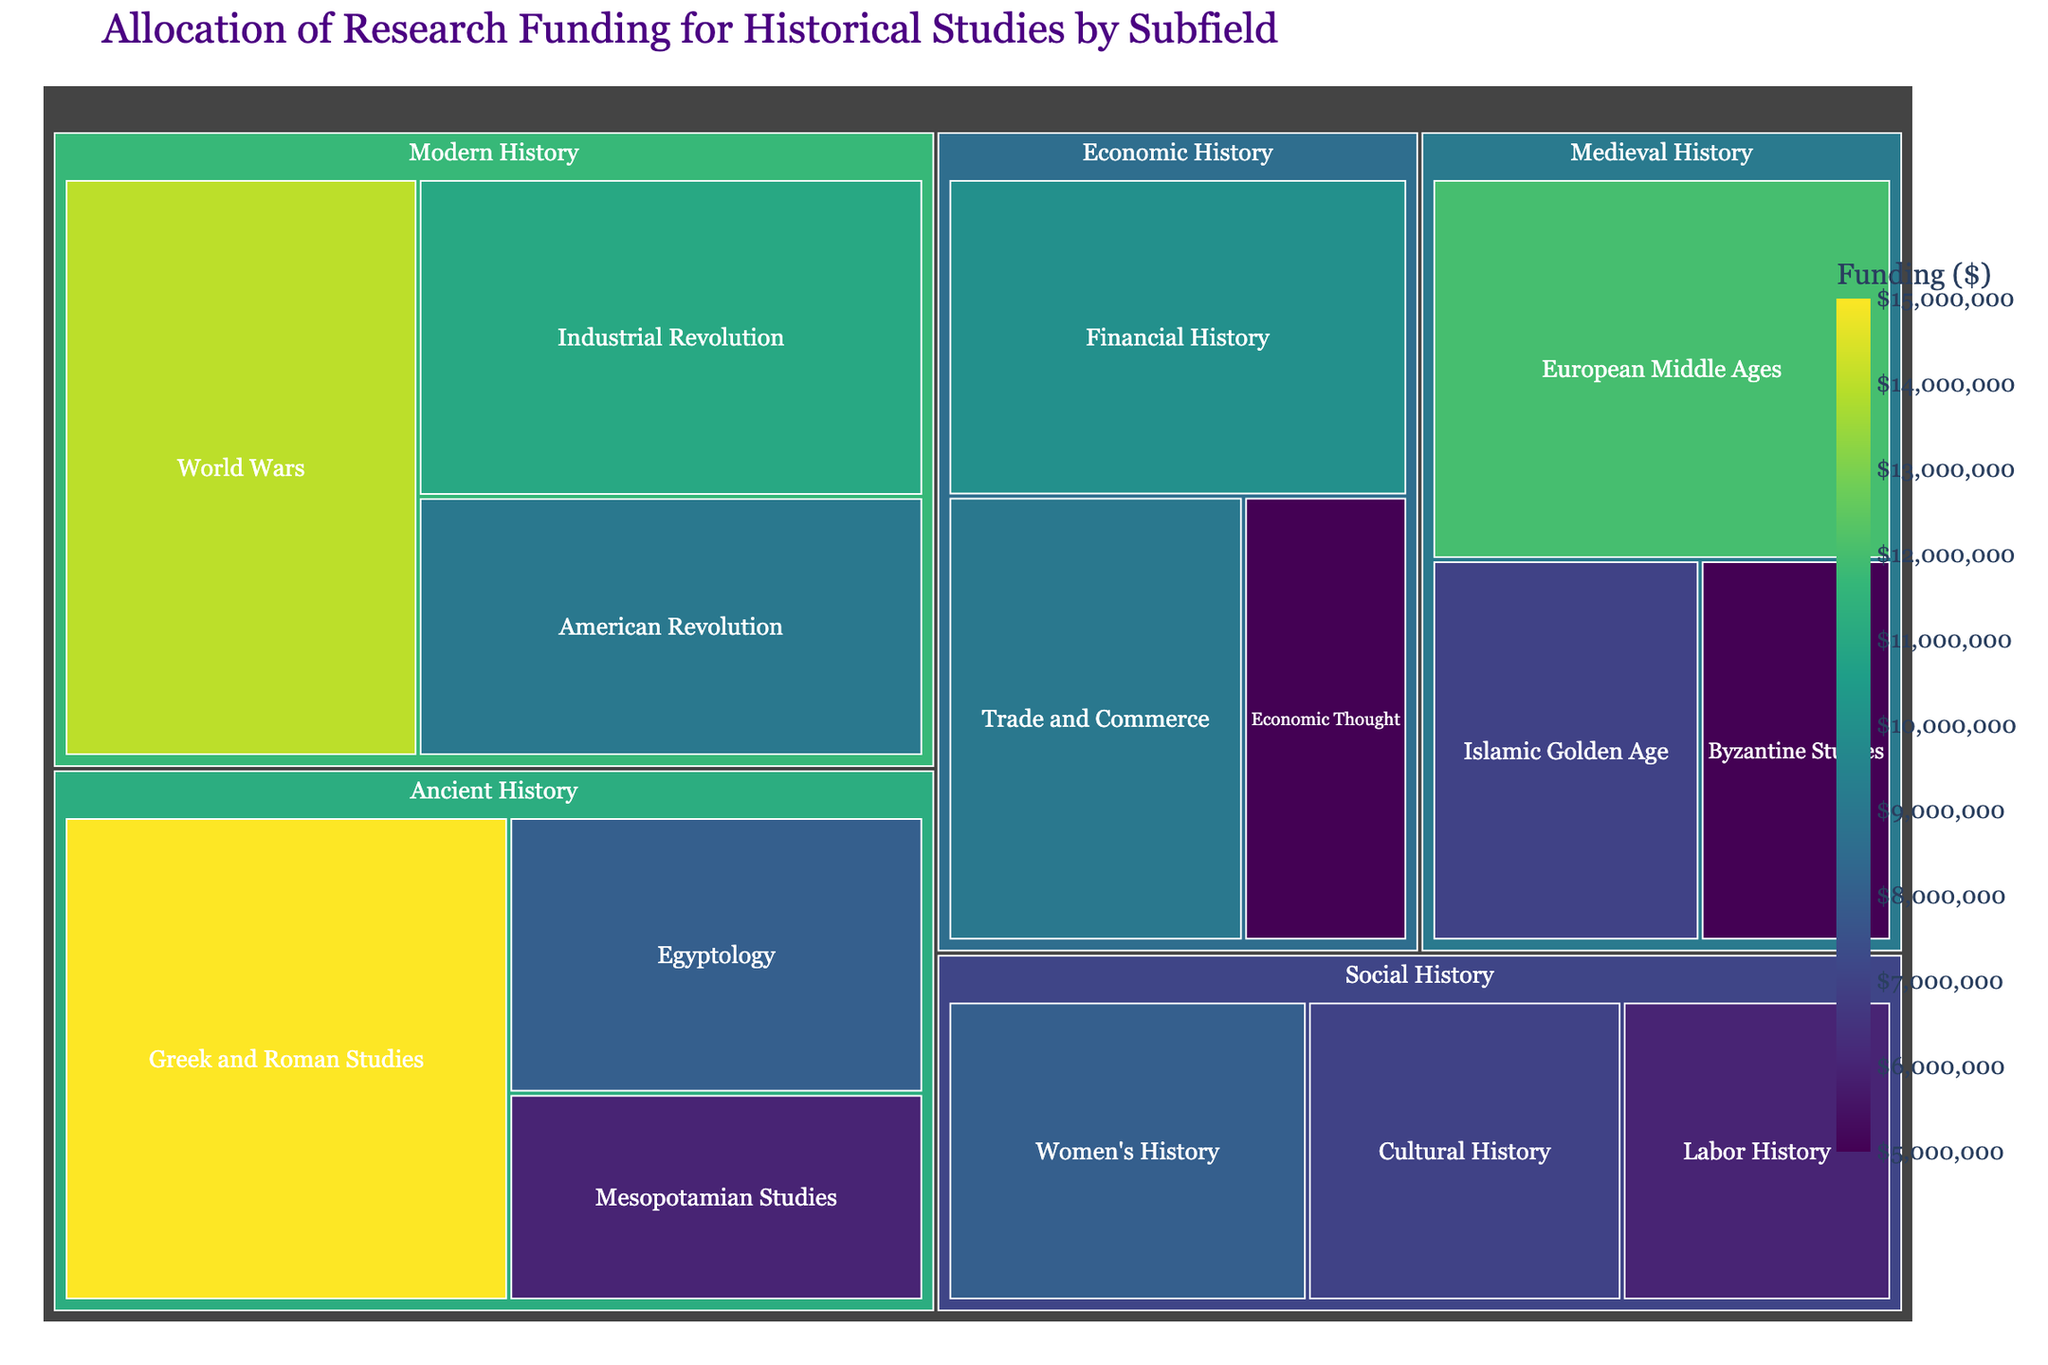How much funding is allocated to the Greek and Roman Studies subfield? The figure shows the funding amount allocated to each subfield within the Ancient History category. For Greek and Roman Studies, the funding is displayed as $15,000,000.
Answer: $15,000,000 What is the total funding allocated to Ancient History? To find the total funding allocated to Ancient History, sum the funding for Greek and Roman Studies ($15,000,000), Egyptology ($8,000,000), and Mesopotamian Studies ($6,000,000): $15,000,000 + $8,000,000 + $6,000,000 = $29,000,000.
Answer: $29,000,000 Which subfield in Medieval History receives the least funding? The Medieval History category includes the subfields European Middle Ages ($12,000,000), Byzantine Studies ($5,000,000), and Islamic Golden Age ($7,000,000). Comparing these, Byzantine Studies has the least funding at $5,000,000.
Answer: Byzantine Studies Is the funding for Cultural History greater than Women's History in Social History? In the Social History category, Cultural History has $7,000,000 and Women's History has $8,000,000. Comparing these, Cultural History has less funding than Women's History.
Answer: No What is the combined funding for subfields in Modern History? To find the combined funding for Modern History, sum the funding for American Revolution ($9,000,000), Industrial Revolution ($11,000,000), and World Wars ($14,000,000): $9,000,000 + $11,000,000 + $14,000,000 = $34,000,000.
Answer: $34,000,000 How does the funding for Islamic Golden Age compare to Industrial Revolution? The funding for Islamic Golden Age is $7,000,000, while the funding for the Industrial Revolution is $11,000,000. The Industrial Revolution has more funding than the Islamic Golden Age.
Answer: Industrial Revolution has more Which subfield has the highest funding within Economic History? In the Economic History category, the subfields are Financial History ($10,000,000), Trade and Commerce ($9,000,000), and Economic Thought ($5,000,000). The subfield with the highest funding is Financial History.
Answer: Financial History What is the average funding of the subfields in Medieval History? The subfields in Medieval History have the following funding amounts: European Middle Ages ($12,000,000), Byzantine Studies ($5,000,000), and Islamic Golden Age ($7,000,000). The sum is $12,000,000 + $5,000,000 + $7,000,000 = $24,000,000. Dividing by 3 subfields gives an average of $24,000,000 / 3 = $8,000,000.
Answer: $8,000,000 What category receives the most total funding? Summing the funding for each category, we get: 
- Ancient History: $29,000,000 
- Medieval History: $24,000,000
- Modern History: $34,000,000
- Social History: $21,000,000
- Economic History: $24,000,000
The category with the most total funding is Modern History with $34,000,000.
Answer: Modern History 